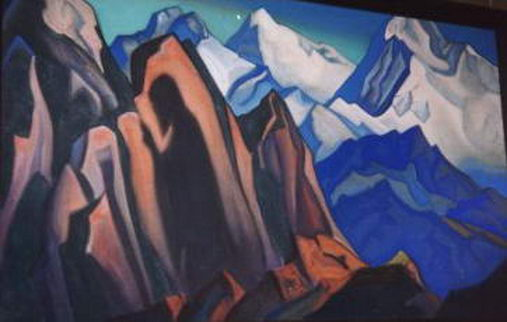Write a detailed description of the given image. The image is a mesmerizing depiction of a mountain landscape, rendered in the unique style of cubism. The artist skillfully employs geometric shapes to create a dynamic and multi-dimensional portrayal of mountains and rocks. The color scheme is predominantly composed of blues, purples, and oranges which contribute to the vivid and energetic mood of the scene. The light blue sky provides a striking contrast to the darker blue hues of the mountains, enhancing the overall visual impact. As a piece of landscape art, this painting encapsulates the beauty and majesty of nature while the cubist technique infuses it with an abstract and modern touch. The interplay of colors and shapes not only highlights the natural scenery but also offers a fresh and thought-provoking perspective on traditional landscape art. 